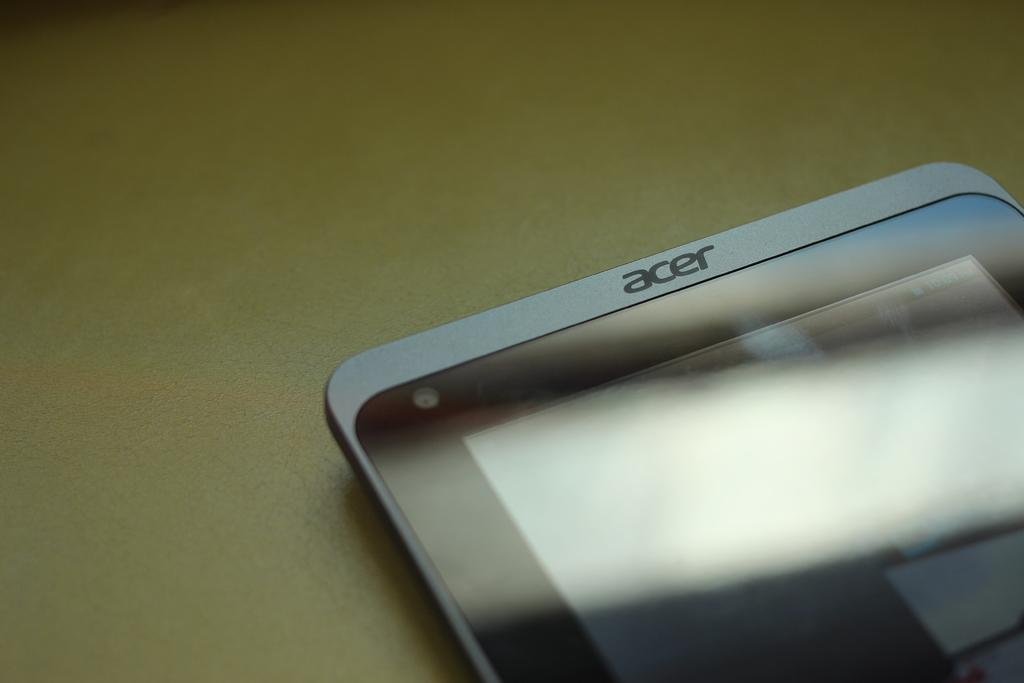<image>
Summarize the visual content of the image. a phone that has the word acer on it 